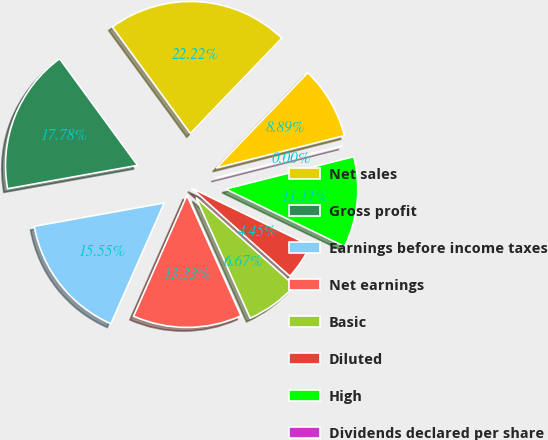Convert chart. <chart><loc_0><loc_0><loc_500><loc_500><pie_chart><fcel>Net sales<fcel>Gross profit<fcel>Earnings before income taxes<fcel>Net earnings<fcel>Basic<fcel>Diluted<fcel>High<fcel>Dividends declared per share<fcel>Low<nl><fcel>22.22%<fcel>17.78%<fcel>15.55%<fcel>13.33%<fcel>6.67%<fcel>4.45%<fcel>11.11%<fcel>0.0%<fcel>8.89%<nl></chart> 